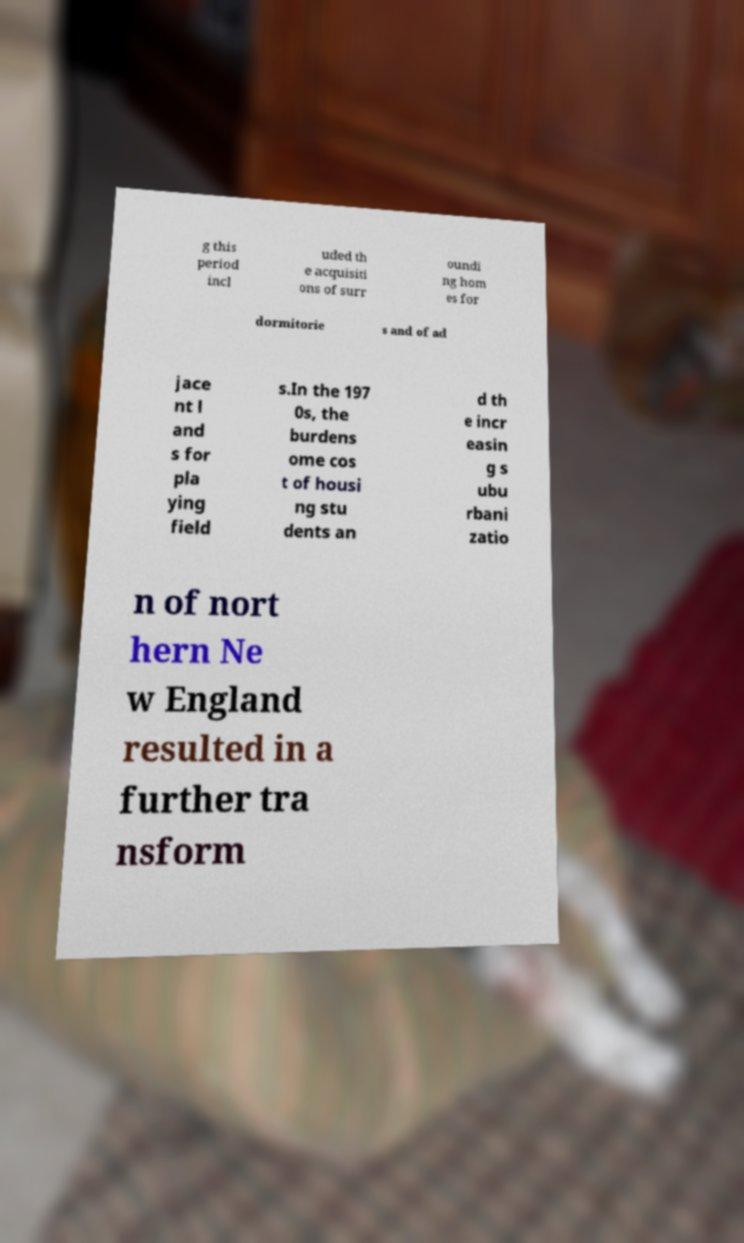Could you extract and type out the text from this image? g this period incl uded th e acquisiti ons of surr oundi ng hom es for dormitorie s and of ad jace nt l and s for pla ying field s.In the 197 0s, the burdens ome cos t of housi ng stu dents an d th e incr easin g s ubu rbani zatio n of nort hern Ne w England resulted in a further tra nsform 